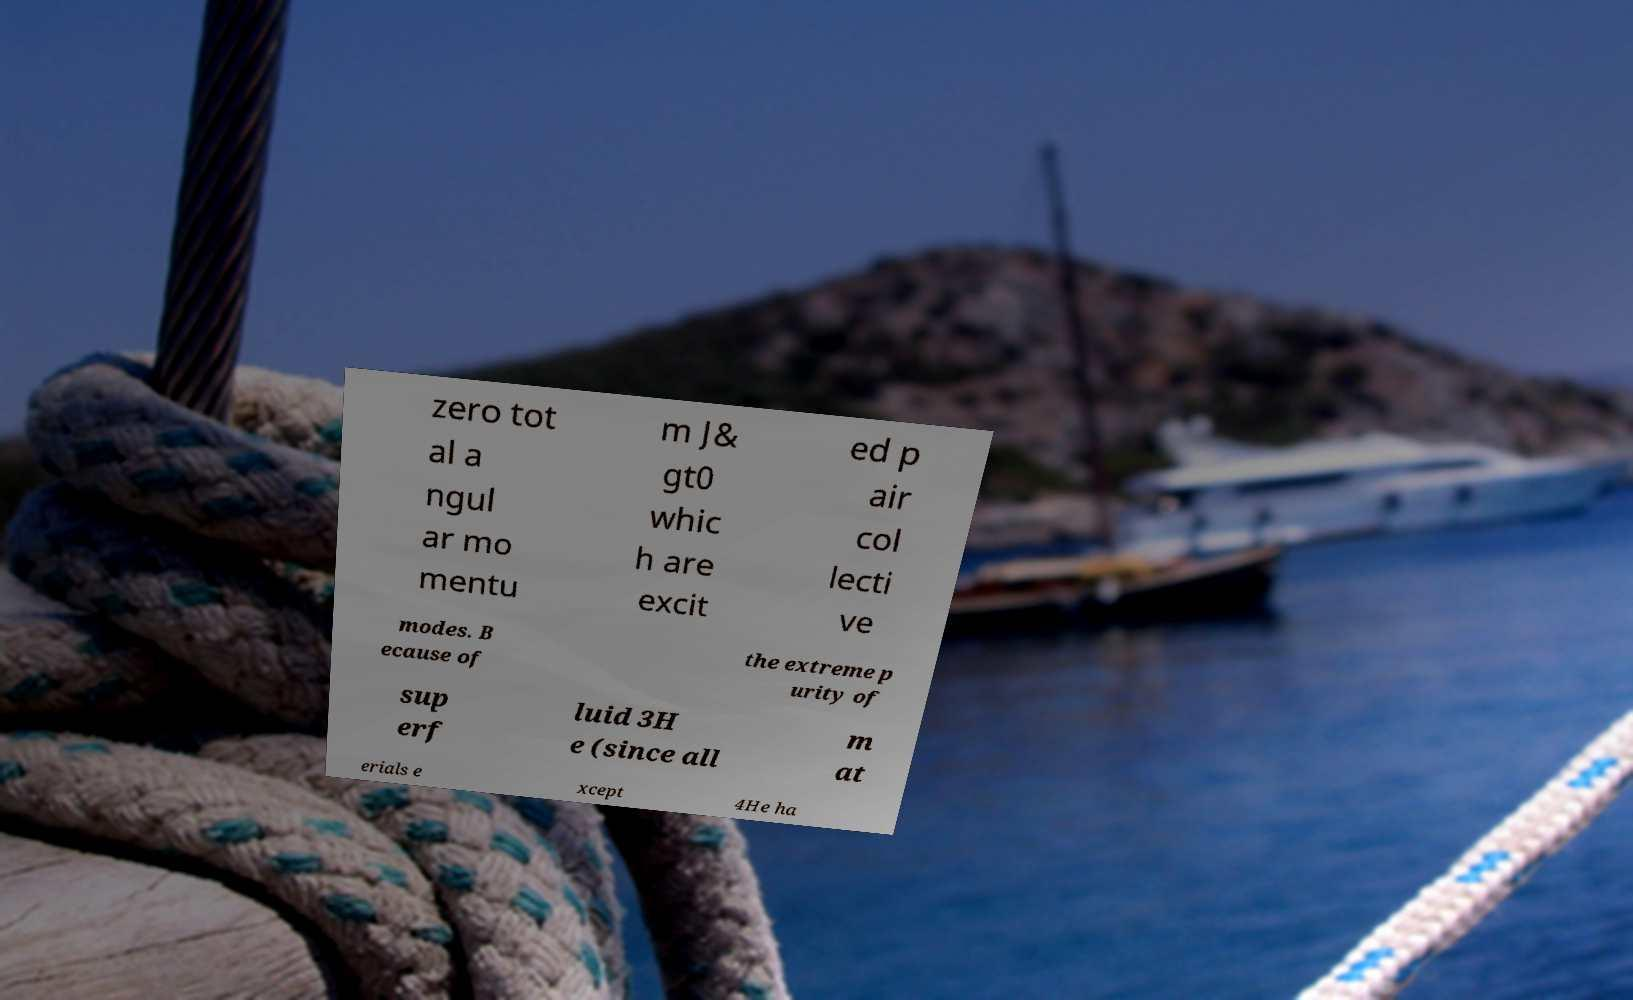Could you extract and type out the text from this image? zero tot al a ngul ar mo mentu m J& gt0 whic h are excit ed p air col lecti ve modes. B ecause of the extreme p urity of sup erf luid 3H e (since all m at erials e xcept 4He ha 